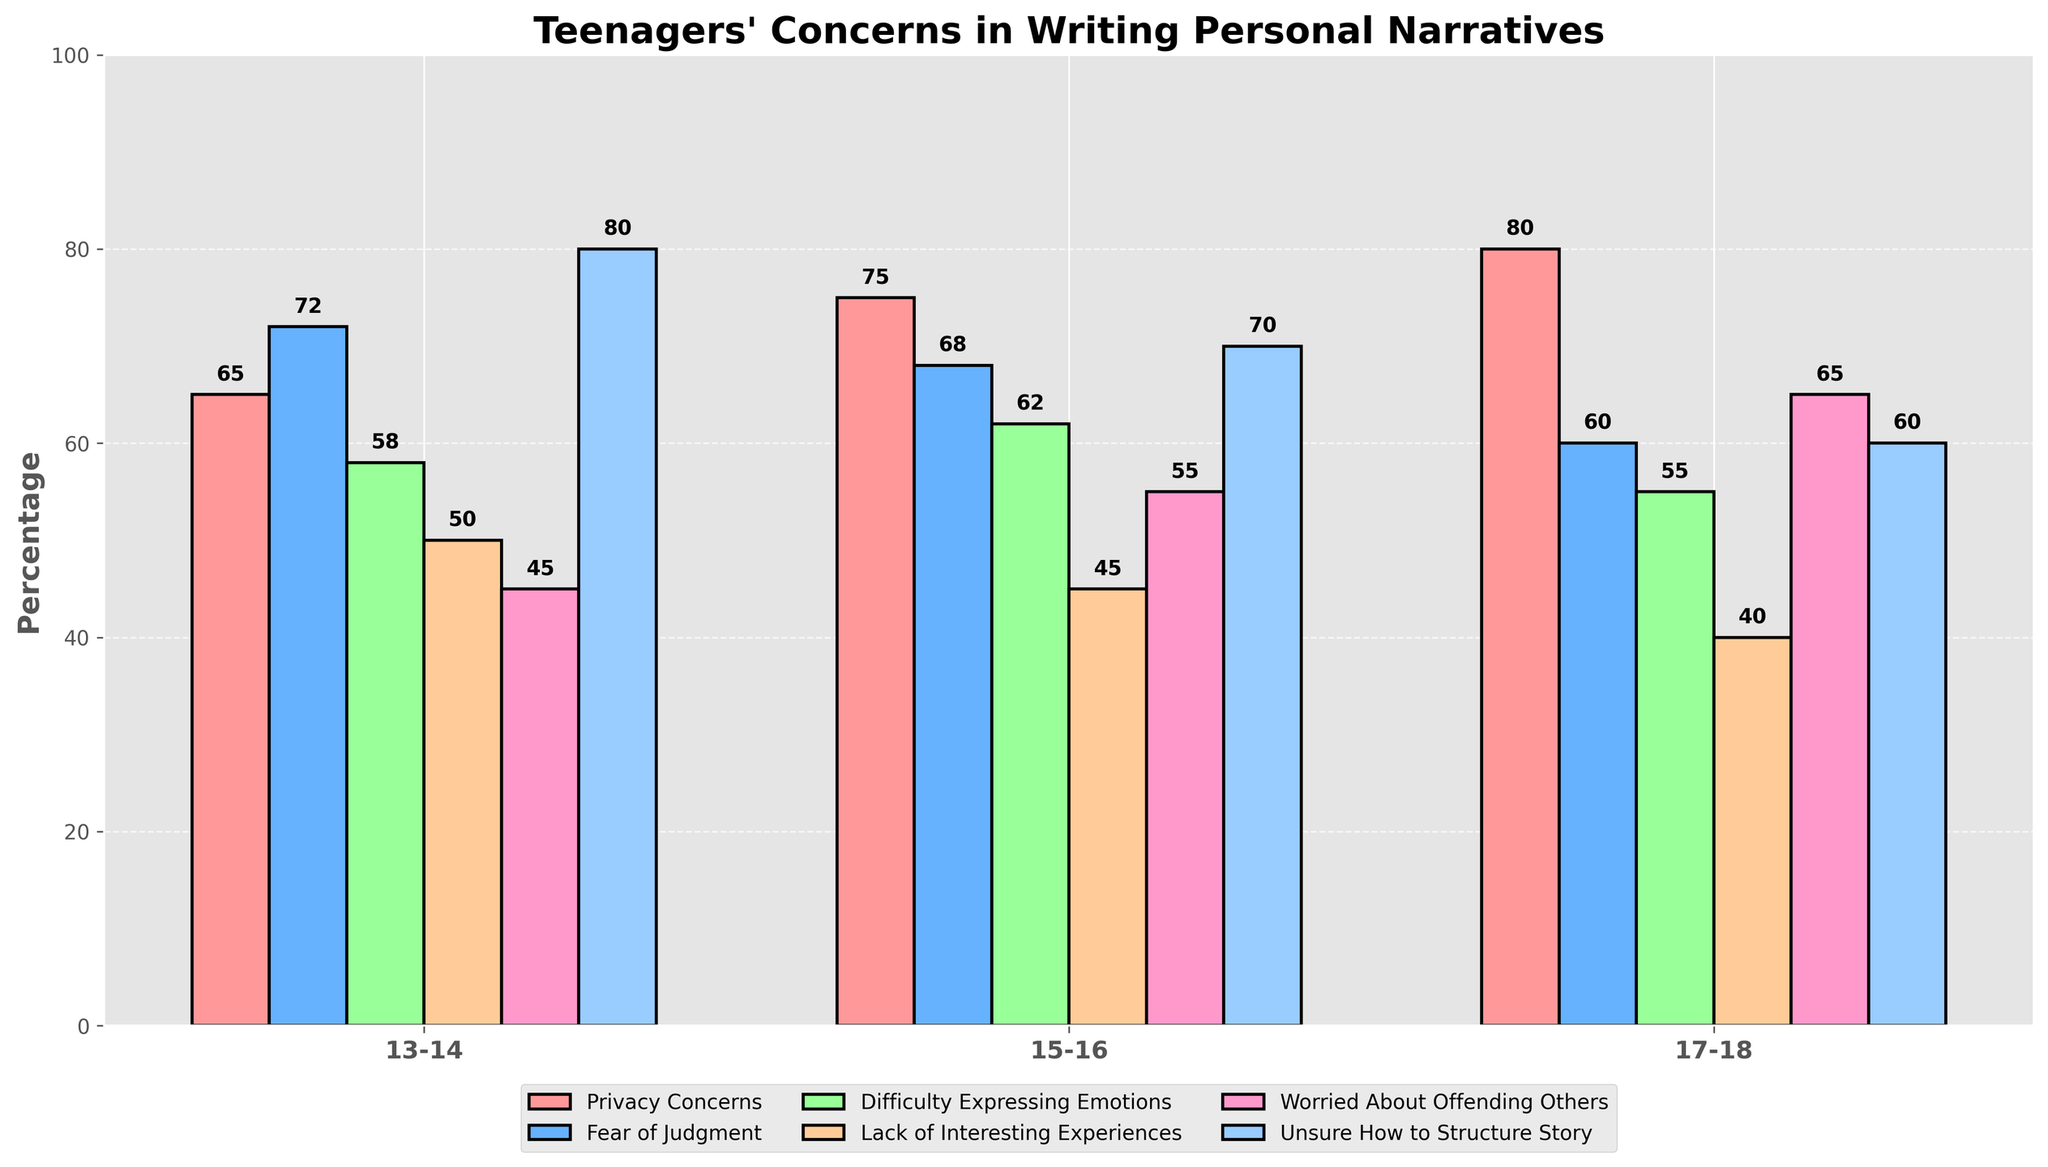Which age group has the highest percentage of privacy concerns? Looking at the bar for Privacy Concerns, the 17-18 age group has the highest value at 80%.
Answer: 17-18 Which common concern is the lowest for the 15-16 age group? Among the concerns for the 15-16 age group, Lack of Interesting Experiences is the lowest, shown by the shortest bar at 45%.
Answer: Lack of Interesting Experiences For the 13-14 age group, how much higher is the percentage of Unsure How to Structure Story compared to Lack of Interesting Experiences? The percentage for Unsure How to Structure Story is 80%, and for Lack of Interesting Experiences, it is 50%. The difference is 80 - 50 = 30%.
Answer: 30% Which concern is most prominent overall across all age groups? Privacy Concerns for the 17-18 age group has the highest percentage overall at 80%, equal to Unsure How to Structure Story for the 13-14 age group.
Answer: Privacy Concerns and Unsure How to Structure Story Compare the percentages of Fear of Judgment between the 13-14 and 17-18 age groups. Which group reports more of this concern and by how much? The 13-14 age group reports 72% for Fear of Judgment, while the 17-18 age group reports 60%. The 13-14 age group reports 72 - 60 = 12% more.
Answer: 13-14 by 12% What is the average percentage of the Worried About Offending Others concern across all age groups? The percentages are 45%, 55%, and 65%. Adding these gives 45 + 55 + 65 = 165, and dividing by 3 gives 165 / 3 = 55%.
Answer: 55% Which age group shows the least difference in percentages between any two concerns? For the 17-18 age group, both Lack of Interesting Experiences and Difficulty Expressing Emotions have the closest values at 40% and 55%, with a difference of 15%.
Answer: 17-18 What is the sum of the percentages for Difficulty Expressing Emotions across all age groups? The percentages are 58% (13-14), 62% (15-16), and 55% (17-18). Adding them gives 58 + 62 + 55 = 175.
Answer: 175% Identify the concern with the largest percentage in the 15-16 age group. Among the concerns for the 15-16 age group, Privacy Concerns is the largest with 75%. This can be identified by the tallest bar.
Answer: Privacy Concerns 